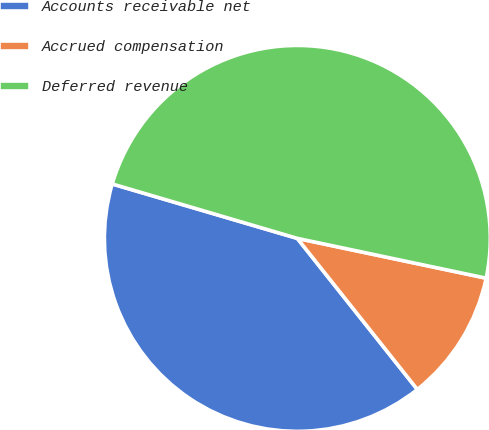<chart> <loc_0><loc_0><loc_500><loc_500><pie_chart><fcel>Accounts receivable net<fcel>Accrued compensation<fcel>Deferred revenue<nl><fcel>40.23%<fcel>11.01%<fcel>48.75%<nl></chart> 